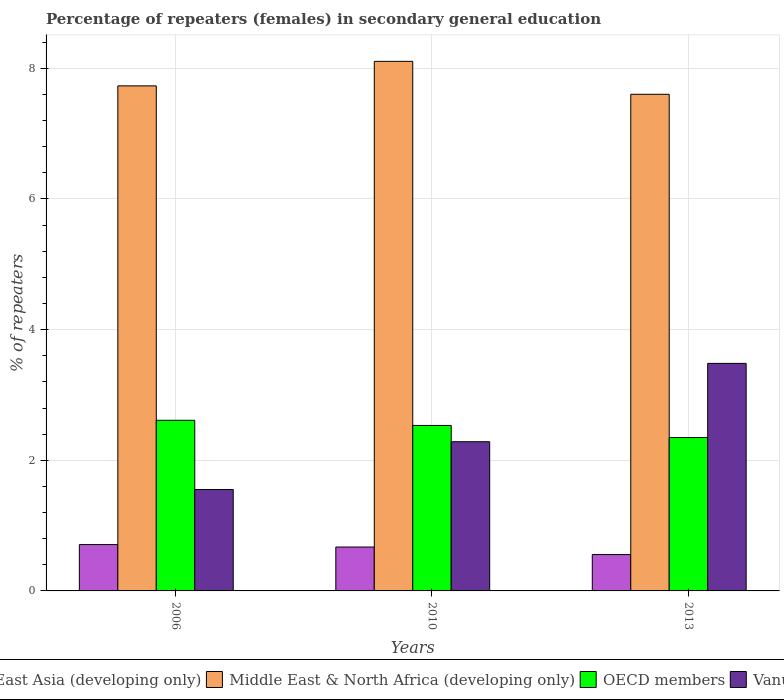How many different coloured bars are there?
Ensure brevity in your answer.  4. How many groups of bars are there?
Your response must be concise. 3. Are the number of bars on each tick of the X-axis equal?
Your answer should be compact. Yes. How many bars are there on the 2nd tick from the right?
Keep it short and to the point. 4. What is the label of the 1st group of bars from the left?
Your answer should be compact. 2006. In how many cases, is the number of bars for a given year not equal to the number of legend labels?
Give a very brief answer. 0. What is the percentage of female repeaters in Middle East & North Africa (developing only) in 2006?
Offer a very short reply. 7.73. Across all years, what is the maximum percentage of female repeaters in Vanuatu?
Provide a succinct answer. 3.48. Across all years, what is the minimum percentage of female repeaters in Middle East & North Africa (developing only)?
Provide a succinct answer. 7.6. What is the total percentage of female repeaters in OECD members in the graph?
Your answer should be very brief. 7.49. What is the difference between the percentage of female repeaters in Middle East & North Africa (developing only) in 2006 and that in 2013?
Your response must be concise. 0.13. What is the difference between the percentage of female repeaters in Vanuatu in 2006 and the percentage of female repeaters in East Asia (developing only) in 2013?
Provide a succinct answer. 1. What is the average percentage of female repeaters in East Asia (developing only) per year?
Keep it short and to the point. 0.65. In the year 2010, what is the difference between the percentage of female repeaters in East Asia (developing only) and percentage of female repeaters in Vanuatu?
Ensure brevity in your answer.  -1.61. What is the ratio of the percentage of female repeaters in Middle East & North Africa (developing only) in 2010 to that in 2013?
Provide a short and direct response. 1.07. What is the difference between the highest and the second highest percentage of female repeaters in OECD members?
Make the answer very short. 0.08. What is the difference between the highest and the lowest percentage of female repeaters in OECD members?
Make the answer very short. 0.26. Is it the case that in every year, the sum of the percentage of female repeaters in OECD members and percentage of female repeaters in Middle East & North Africa (developing only) is greater than the sum of percentage of female repeaters in East Asia (developing only) and percentage of female repeaters in Vanuatu?
Provide a succinct answer. Yes. What does the 3rd bar from the right in 2010 represents?
Your answer should be compact. Middle East & North Africa (developing only). How many bars are there?
Offer a very short reply. 12. Are all the bars in the graph horizontal?
Offer a terse response. No. Does the graph contain any zero values?
Your answer should be compact. No. Where does the legend appear in the graph?
Ensure brevity in your answer.  Bottom center. How many legend labels are there?
Your response must be concise. 4. How are the legend labels stacked?
Make the answer very short. Horizontal. What is the title of the graph?
Keep it short and to the point. Percentage of repeaters (females) in secondary general education. What is the label or title of the X-axis?
Your answer should be very brief. Years. What is the label or title of the Y-axis?
Ensure brevity in your answer.  % of repeaters. What is the % of repeaters of East Asia (developing only) in 2006?
Provide a succinct answer. 0.71. What is the % of repeaters in Middle East & North Africa (developing only) in 2006?
Keep it short and to the point. 7.73. What is the % of repeaters in OECD members in 2006?
Offer a terse response. 2.61. What is the % of repeaters of Vanuatu in 2006?
Offer a terse response. 1.55. What is the % of repeaters of East Asia (developing only) in 2010?
Offer a very short reply. 0.67. What is the % of repeaters of Middle East & North Africa (developing only) in 2010?
Provide a succinct answer. 8.11. What is the % of repeaters of OECD members in 2010?
Make the answer very short. 2.53. What is the % of repeaters in Vanuatu in 2010?
Ensure brevity in your answer.  2.28. What is the % of repeaters in East Asia (developing only) in 2013?
Offer a terse response. 0.56. What is the % of repeaters of Middle East & North Africa (developing only) in 2013?
Your response must be concise. 7.6. What is the % of repeaters of OECD members in 2013?
Ensure brevity in your answer.  2.35. What is the % of repeaters of Vanuatu in 2013?
Provide a short and direct response. 3.48. Across all years, what is the maximum % of repeaters in East Asia (developing only)?
Provide a short and direct response. 0.71. Across all years, what is the maximum % of repeaters in Middle East & North Africa (developing only)?
Your answer should be compact. 8.11. Across all years, what is the maximum % of repeaters in OECD members?
Your answer should be compact. 2.61. Across all years, what is the maximum % of repeaters of Vanuatu?
Keep it short and to the point. 3.48. Across all years, what is the minimum % of repeaters of East Asia (developing only)?
Provide a succinct answer. 0.56. Across all years, what is the minimum % of repeaters of Middle East & North Africa (developing only)?
Keep it short and to the point. 7.6. Across all years, what is the minimum % of repeaters in OECD members?
Provide a short and direct response. 2.35. Across all years, what is the minimum % of repeaters in Vanuatu?
Give a very brief answer. 1.55. What is the total % of repeaters of East Asia (developing only) in the graph?
Your response must be concise. 1.94. What is the total % of repeaters in Middle East & North Africa (developing only) in the graph?
Provide a short and direct response. 23.44. What is the total % of repeaters of OECD members in the graph?
Provide a short and direct response. 7.49. What is the total % of repeaters in Vanuatu in the graph?
Ensure brevity in your answer.  7.32. What is the difference between the % of repeaters of East Asia (developing only) in 2006 and that in 2010?
Your response must be concise. 0.04. What is the difference between the % of repeaters of Middle East & North Africa (developing only) in 2006 and that in 2010?
Your answer should be very brief. -0.38. What is the difference between the % of repeaters of OECD members in 2006 and that in 2010?
Provide a succinct answer. 0.08. What is the difference between the % of repeaters in Vanuatu in 2006 and that in 2010?
Give a very brief answer. -0.73. What is the difference between the % of repeaters in East Asia (developing only) in 2006 and that in 2013?
Ensure brevity in your answer.  0.15. What is the difference between the % of repeaters in Middle East & North Africa (developing only) in 2006 and that in 2013?
Ensure brevity in your answer.  0.13. What is the difference between the % of repeaters of OECD members in 2006 and that in 2013?
Make the answer very short. 0.26. What is the difference between the % of repeaters of Vanuatu in 2006 and that in 2013?
Your response must be concise. -1.93. What is the difference between the % of repeaters of East Asia (developing only) in 2010 and that in 2013?
Your response must be concise. 0.12. What is the difference between the % of repeaters in Middle East & North Africa (developing only) in 2010 and that in 2013?
Give a very brief answer. 0.5. What is the difference between the % of repeaters of OECD members in 2010 and that in 2013?
Ensure brevity in your answer.  0.19. What is the difference between the % of repeaters of Vanuatu in 2010 and that in 2013?
Provide a short and direct response. -1.2. What is the difference between the % of repeaters of East Asia (developing only) in 2006 and the % of repeaters of Middle East & North Africa (developing only) in 2010?
Ensure brevity in your answer.  -7.4. What is the difference between the % of repeaters in East Asia (developing only) in 2006 and the % of repeaters in OECD members in 2010?
Your answer should be compact. -1.82. What is the difference between the % of repeaters in East Asia (developing only) in 2006 and the % of repeaters in Vanuatu in 2010?
Make the answer very short. -1.57. What is the difference between the % of repeaters of Middle East & North Africa (developing only) in 2006 and the % of repeaters of OECD members in 2010?
Make the answer very short. 5.2. What is the difference between the % of repeaters of Middle East & North Africa (developing only) in 2006 and the % of repeaters of Vanuatu in 2010?
Ensure brevity in your answer.  5.45. What is the difference between the % of repeaters of OECD members in 2006 and the % of repeaters of Vanuatu in 2010?
Your answer should be compact. 0.33. What is the difference between the % of repeaters in East Asia (developing only) in 2006 and the % of repeaters in Middle East & North Africa (developing only) in 2013?
Ensure brevity in your answer.  -6.89. What is the difference between the % of repeaters in East Asia (developing only) in 2006 and the % of repeaters in OECD members in 2013?
Make the answer very short. -1.64. What is the difference between the % of repeaters in East Asia (developing only) in 2006 and the % of repeaters in Vanuatu in 2013?
Make the answer very short. -2.77. What is the difference between the % of repeaters in Middle East & North Africa (developing only) in 2006 and the % of repeaters in OECD members in 2013?
Your answer should be compact. 5.38. What is the difference between the % of repeaters in Middle East & North Africa (developing only) in 2006 and the % of repeaters in Vanuatu in 2013?
Provide a short and direct response. 4.25. What is the difference between the % of repeaters of OECD members in 2006 and the % of repeaters of Vanuatu in 2013?
Make the answer very short. -0.87. What is the difference between the % of repeaters in East Asia (developing only) in 2010 and the % of repeaters in Middle East & North Africa (developing only) in 2013?
Keep it short and to the point. -6.93. What is the difference between the % of repeaters of East Asia (developing only) in 2010 and the % of repeaters of OECD members in 2013?
Offer a very short reply. -1.68. What is the difference between the % of repeaters in East Asia (developing only) in 2010 and the % of repeaters in Vanuatu in 2013?
Ensure brevity in your answer.  -2.81. What is the difference between the % of repeaters of Middle East & North Africa (developing only) in 2010 and the % of repeaters of OECD members in 2013?
Make the answer very short. 5.76. What is the difference between the % of repeaters in Middle East & North Africa (developing only) in 2010 and the % of repeaters in Vanuatu in 2013?
Make the answer very short. 4.62. What is the difference between the % of repeaters of OECD members in 2010 and the % of repeaters of Vanuatu in 2013?
Your response must be concise. -0.95. What is the average % of repeaters in East Asia (developing only) per year?
Offer a very short reply. 0.65. What is the average % of repeaters in Middle East & North Africa (developing only) per year?
Offer a terse response. 7.81. What is the average % of repeaters in OECD members per year?
Ensure brevity in your answer.  2.5. What is the average % of repeaters of Vanuatu per year?
Your answer should be very brief. 2.44. In the year 2006, what is the difference between the % of repeaters in East Asia (developing only) and % of repeaters in Middle East & North Africa (developing only)?
Ensure brevity in your answer.  -7.02. In the year 2006, what is the difference between the % of repeaters in East Asia (developing only) and % of repeaters in OECD members?
Offer a terse response. -1.9. In the year 2006, what is the difference between the % of repeaters of East Asia (developing only) and % of repeaters of Vanuatu?
Make the answer very short. -0.84. In the year 2006, what is the difference between the % of repeaters of Middle East & North Africa (developing only) and % of repeaters of OECD members?
Your answer should be very brief. 5.12. In the year 2006, what is the difference between the % of repeaters of Middle East & North Africa (developing only) and % of repeaters of Vanuatu?
Give a very brief answer. 6.18. In the year 2006, what is the difference between the % of repeaters of OECD members and % of repeaters of Vanuatu?
Your answer should be very brief. 1.06. In the year 2010, what is the difference between the % of repeaters in East Asia (developing only) and % of repeaters in Middle East & North Africa (developing only)?
Give a very brief answer. -7.43. In the year 2010, what is the difference between the % of repeaters in East Asia (developing only) and % of repeaters in OECD members?
Ensure brevity in your answer.  -1.86. In the year 2010, what is the difference between the % of repeaters in East Asia (developing only) and % of repeaters in Vanuatu?
Offer a terse response. -1.61. In the year 2010, what is the difference between the % of repeaters in Middle East & North Africa (developing only) and % of repeaters in OECD members?
Give a very brief answer. 5.57. In the year 2010, what is the difference between the % of repeaters of Middle East & North Africa (developing only) and % of repeaters of Vanuatu?
Your answer should be very brief. 5.82. In the year 2010, what is the difference between the % of repeaters in OECD members and % of repeaters in Vanuatu?
Make the answer very short. 0.25. In the year 2013, what is the difference between the % of repeaters of East Asia (developing only) and % of repeaters of Middle East & North Africa (developing only)?
Provide a succinct answer. -7.05. In the year 2013, what is the difference between the % of repeaters in East Asia (developing only) and % of repeaters in OECD members?
Ensure brevity in your answer.  -1.79. In the year 2013, what is the difference between the % of repeaters in East Asia (developing only) and % of repeaters in Vanuatu?
Your answer should be compact. -2.93. In the year 2013, what is the difference between the % of repeaters in Middle East & North Africa (developing only) and % of repeaters in OECD members?
Provide a short and direct response. 5.25. In the year 2013, what is the difference between the % of repeaters of Middle East & North Africa (developing only) and % of repeaters of Vanuatu?
Your response must be concise. 4.12. In the year 2013, what is the difference between the % of repeaters of OECD members and % of repeaters of Vanuatu?
Give a very brief answer. -1.14. What is the ratio of the % of repeaters of East Asia (developing only) in 2006 to that in 2010?
Provide a short and direct response. 1.06. What is the ratio of the % of repeaters in Middle East & North Africa (developing only) in 2006 to that in 2010?
Offer a very short reply. 0.95. What is the ratio of the % of repeaters in OECD members in 2006 to that in 2010?
Make the answer very short. 1.03. What is the ratio of the % of repeaters in Vanuatu in 2006 to that in 2010?
Offer a terse response. 0.68. What is the ratio of the % of repeaters in East Asia (developing only) in 2006 to that in 2013?
Keep it short and to the point. 1.27. What is the ratio of the % of repeaters in Middle East & North Africa (developing only) in 2006 to that in 2013?
Provide a succinct answer. 1.02. What is the ratio of the % of repeaters in OECD members in 2006 to that in 2013?
Provide a short and direct response. 1.11. What is the ratio of the % of repeaters in Vanuatu in 2006 to that in 2013?
Offer a very short reply. 0.45. What is the ratio of the % of repeaters of East Asia (developing only) in 2010 to that in 2013?
Offer a terse response. 1.21. What is the ratio of the % of repeaters of Middle East & North Africa (developing only) in 2010 to that in 2013?
Offer a very short reply. 1.07. What is the ratio of the % of repeaters in OECD members in 2010 to that in 2013?
Your response must be concise. 1.08. What is the ratio of the % of repeaters in Vanuatu in 2010 to that in 2013?
Keep it short and to the point. 0.66. What is the difference between the highest and the second highest % of repeaters of East Asia (developing only)?
Give a very brief answer. 0.04. What is the difference between the highest and the second highest % of repeaters of Middle East & North Africa (developing only)?
Keep it short and to the point. 0.38. What is the difference between the highest and the second highest % of repeaters of OECD members?
Keep it short and to the point. 0.08. What is the difference between the highest and the second highest % of repeaters in Vanuatu?
Offer a terse response. 1.2. What is the difference between the highest and the lowest % of repeaters in East Asia (developing only)?
Give a very brief answer. 0.15. What is the difference between the highest and the lowest % of repeaters of Middle East & North Africa (developing only)?
Your response must be concise. 0.5. What is the difference between the highest and the lowest % of repeaters of OECD members?
Provide a succinct answer. 0.26. What is the difference between the highest and the lowest % of repeaters of Vanuatu?
Keep it short and to the point. 1.93. 